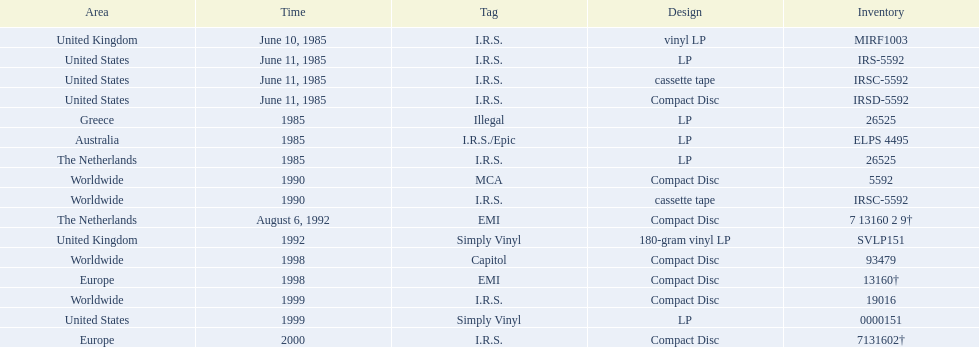Which region was the last to release? Europe. 